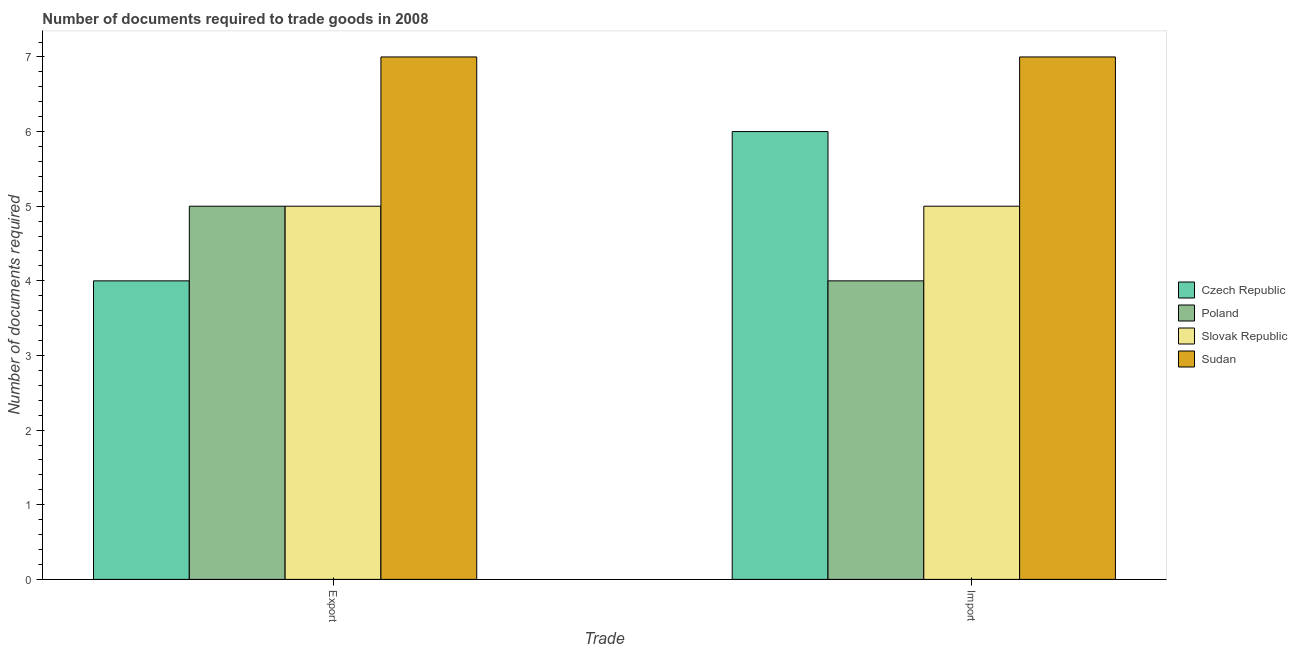How many different coloured bars are there?
Provide a short and direct response. 4. How many groups of bars are there?
Offer a very short reply. 2. What is the label of the 2nd group of bars from the left?
Offer a terse response. Import. What is the number of documents required to export goods in Czech Republic?
Provide a short and direct response. 4. Across all countries, what is the maximum number of documents required to import goods?
Ensure brevity in your answer.  7. Across all countries, what is the minimum number of documents required to import goods?
Your answer should be very brief. 4. In which country was the number of documents required to import goods maximum?
Your response must be concise. Sudan. In which country was the number of documents required to import goods minimum?
Keep it short and to the point. Poland. What is the total number of documents required to export goods in the graph?
Ensure brevity in your answer.  21. What is the difference between the number of documents required to export goods in Slovak Republic and that in Poland?
Your answer should be compact. 0. What is the difference between the number of documents required to export goods in Slovak Republic and the number of documents required to import goods in Sudan?
Offer a terse response. -2. What is the average number of documents required to export goods per country?
Provide a succinct answer. 5.25. What is the difference between the number of documents required to import goods and number of documents required to export goods in Poland?
Provide a short and direct response. -1. In how many countries, is the number of documents required to export goods greater than 4.6 ?
Provide a succinct answer. 3. Is the number of documents required to export goods in Slovak Republic less than that in Sudan?
Provide a short and direct response. Yes. What does the 4th bar from the left in Export represents?
Provide a short and direct response. Sudan. What does the 3rd bar from the right in Import represents?
Offer a very short reply. Poland. How many bars are there?
Make the answer very short. 8. How many countries are there in the graph?
Provide a succinct answer. 4. What is the difference between two consecutive major ticks on the Y-axis?
Give a very brief answer. 1. Does the graph contain any zero values?
Give a very brief answer. No. Where does the legend appear in the graph?
Your answer should be very brief. Center right. How many legend labels are there?
Offer a terse response. 4. How are the legend labels stacked?
Give a very brief answer. Vertical. What is the title of the graph?
Your answer should be very brief. Number of documents required to trade goods in 2008. What is the label or title of the X-axis?
Your answer should be very brief. Trade. What is the label or title of the Y-axis?
Offer a terse response. Number of documents required. What is the Number of documents required in Poland in Export?
Your answer should be compact. 5. What is the Number of documents required of Slovak Republic in Export?
Your answer should be very brief. 5. What is the Number of documents required in Slovak Republic in Import?
Your answer should be very brief. 5. Across all Trade, what is the maximum Number of documents required of Czech Republic?
Provide a succinct answer. 6. Across all Trade, what is the maximum Number of documents required in Slovak Republic?
Ensure brevity in your answer.  5. Across all Trade, what is the maximum Number of documents required in Sudan?
Give a very brief answer. 7. Across all Trade, what is the minimum Number of documents required in Poland?
Your response must be concise. 4. Across all Trade, what is the minimum Number of documents required in Slovak Republic?
Keep it short and to the point. 5. Across all Trade, what is the minimum Number of documents required in Sudan?
Offer a very short reply. 7. What is the total Number of documents required of Sudan in the graph?
Your answer should be compact. 14. What is the difference between the Number of documents required of Slovak Republic in Export and that in Import?
Provide a short and direct response. 0. What is the difference between the Number of documents required in Czech Republic in Export and the Number of documents required in Slovak Republic in Import?
Your response must be concise. -1. What is the difference between the Number of documents required of Poland in Export and the Number of documents required of Sudan in Import?
Keep it short and to the point. -2. What is the average Number of documents required in Czech Republic per Trade?
Provide a short and direct response. 5. What is the average Number of documents required in Poland per Trade?
Make the answer very short. 4.5. What is the difference between the Number of documents required in Czech Republic and Number of documents required in Slovak Republic in Import?
Offer a very short reply. 1. What is the difference between the Number of documents required in Poland and Number of documents required in Sudan in Import?
Your answer should be compact. -3. What is the ratio of the Number of documents required in Czech Republic in Export to that in Import?
Your answer should be compact. 0.67. What is the ratio of the Number of documents required in Poland in Export to that in Import?
Provide a short and direct response. 1.25. What is the ratio of the Number of documents required in Slovak Republic in Export to that in Import?
Provide a short and direct response. 1. What is the ratio of the Number of documents required in Sudan in Export to that in Import?
Provide a short and direct response. 1. What is the difference between the highest and the second highest Number of documents required in Slovak Republic?
Make the answer very short. 0. What is the difference between the highest and the second highest Number of documents required of Sudan?
Provide a short and direct response. 0. What is the difference between the highest and the lowest Number of documents required of Poland?
Keep it short and to the point. 1. 